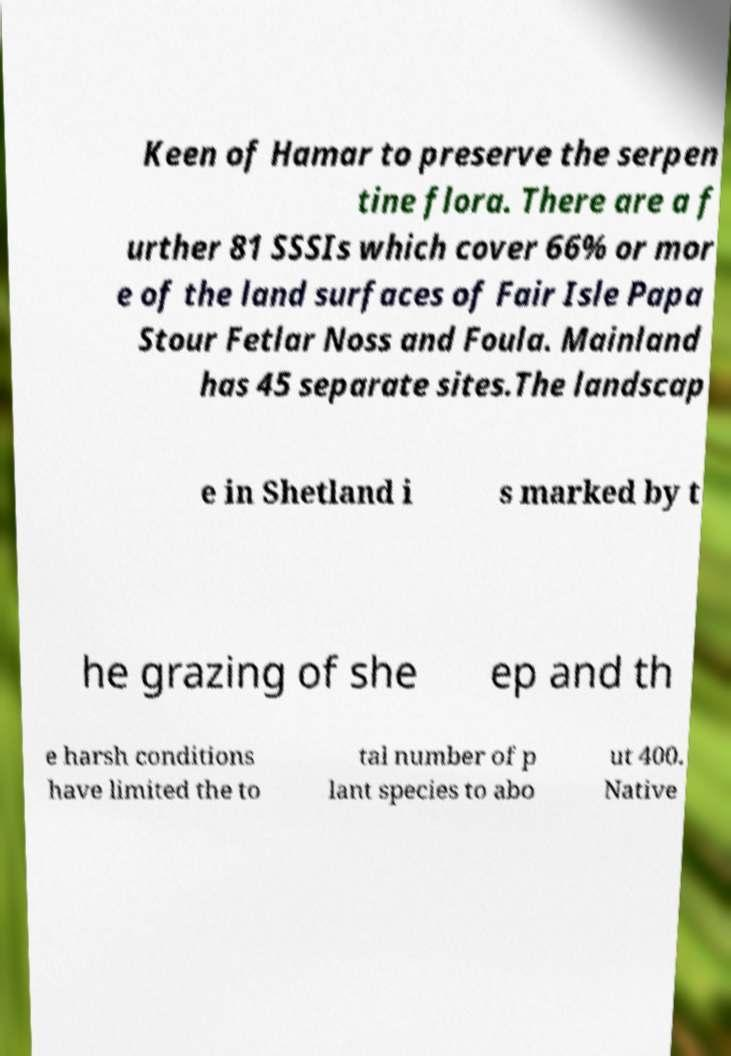Could you extract and type out the text from this image? Keen of Hamar to preserve the serpen tine flora. There are a f urther 81 SSSIs which cover 66% or mor e of the land surfaces of Fair Isle Papa Stour Fetlar Noss and Foula. Mainland has 45 separate sites.The landscap e in Shetland i s marked by t he grazing of she ep and th e harsh conditions have limited the to tal number of p lant species to abo ut 400. Native 